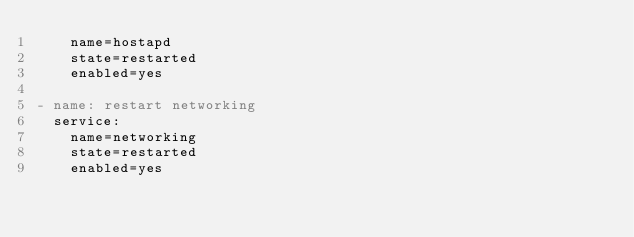Convert code to text. <code><loc_0><loc_0><loc_500><loc_500><_YAML_>    name=hostapd
    state=restarted
    enabled=yes

- name: restart networking
  service:
    name=networking
    state=restarted
    enabled=yes</code> 